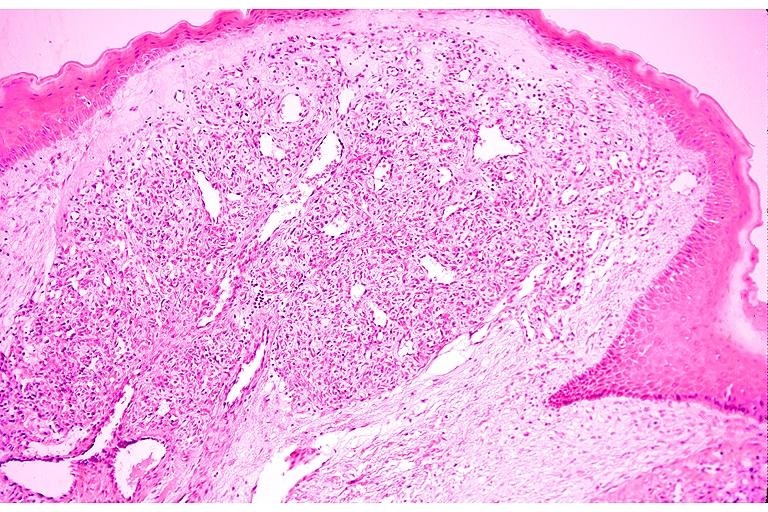where is this?
Answer the question using a single word or phrase. Oral 